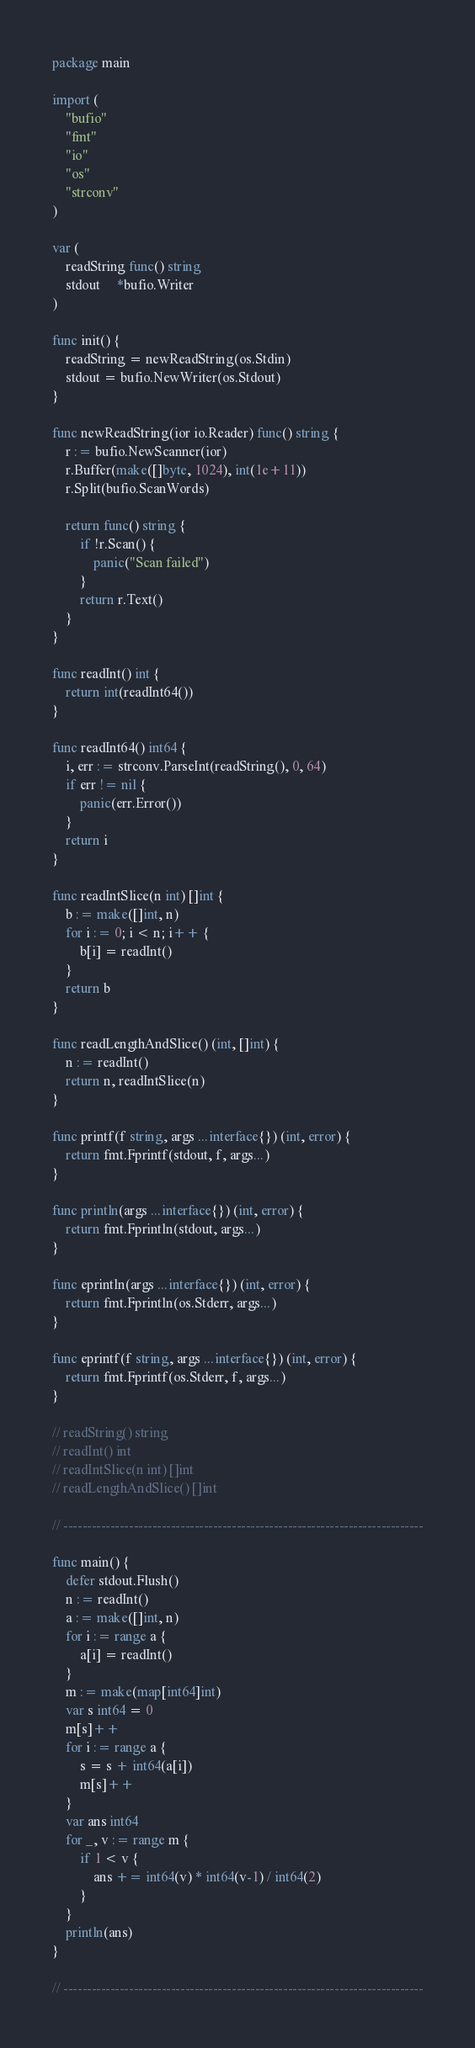Convert code to text. <code><loc_0><loc_0><loc_500><loc_500><_Go_>package main

import (
	"bufio"
	"fmt"
	"io"
	"os"
	"strconv"
)

var (
	readString func() string
	stdout     *bufio.Writer
)

func init() {
	readString = newReadString(os.Stdin)
	stdout = bufio.NewWriter(os.Stdout)
}

func newReadString(ior io.Reader) func() string {
	r := bufio.NewScanner(ior)
	r.Buffer(make([]byte, 1024), int(1e+11))
	r.Split(bufio.ScanWords)

	return func() string {
		if !r.Scan() {
			panic("Scan failed")
		}
		return r.Text()
	}
}

func readInt() int {
	return int(readInt64())
}

func readInt64() int64 {
	i, err := strconv.ParseInt(readString(), 0, 64)
	if err != nil {
		panic(err.Error())
	}
	return i
}

func readIntSlice(n int) []int {
	b := make([]int, n)
	for i := 0; i < n; i++ {
		b[i] = readInt()
	}
	return b
}

func readLengthAndSlice() (int, []int) {
	n := readInt()
	return n, readIntSlice(n)
}

func printf(f string, args ...interface{}) (int, error) {
	return fmt.Fprintf(stdout, f, args...)
}

func println(args ...interface{}) (int, error) {
	return fmt.Fprintln(stdout, args...)
}

func eprintln(args ...interface{}) (int, error) {
	return fmt.Fprintln(os.Stderr, args...)
}

func eprintf(f string, args ...interface{}) (int, error) {
	return fmt.Fprintf(os.Stderr, f, args...)
}

// readString() string
// readInt() int
// readIntSlice(n int) []int
// readLengthAndSlice() []int

// -----------------------------------------------------------------------------

func main() {
	defer stdout.Flush()
	n := readInt()
	a := make([]int, n)
	for i := range a {
		a[i] = readInt()
	}
	m := make(map[int64]int)
	var s int64 = 0
	m[s]++
	for i := range a {
		s = s + int64(a[i])
		m[s]++
	}
	var ans int64
	for _, v := range m {
		if 1 < v {
			ans += int64(v) * int64(v-1) / int64(2)
		}
	}
	println(ans)
}

// -----------------------------------------------------------------------------
</code> 